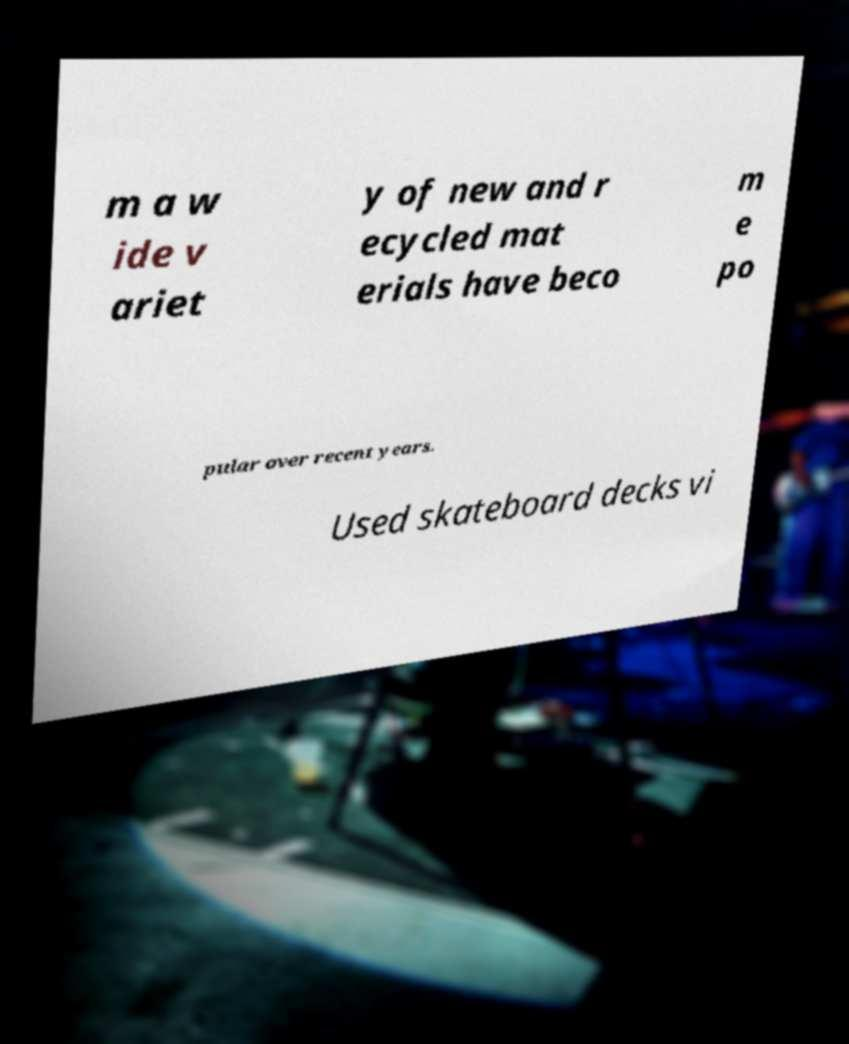What messages or text are displayed in this image? I need them in a readable, typed format. m a w ide v ariet y of new and r ecycled mat erials have beco m e po pular over recent years. Used skateboard decks vi 